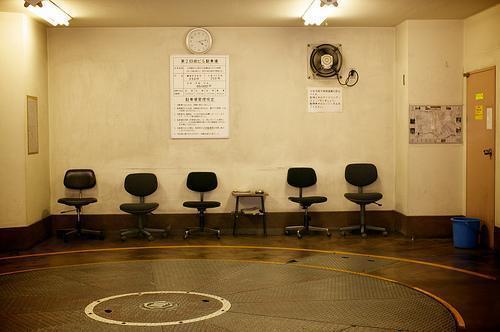How many chairs are there?
Give a very brief answer. 5. How many tables are there?
Give a very brief answer. 1. 